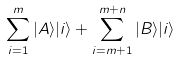<formula> <loc_0><loc_0><loc_500><loc_500>\sum _ { i = 1 } ^ { m } | A \rangle | i \rangle + \sum _ { i = m + 1 } ^ { m + n } | B \rangle | i \rangle</formula> 